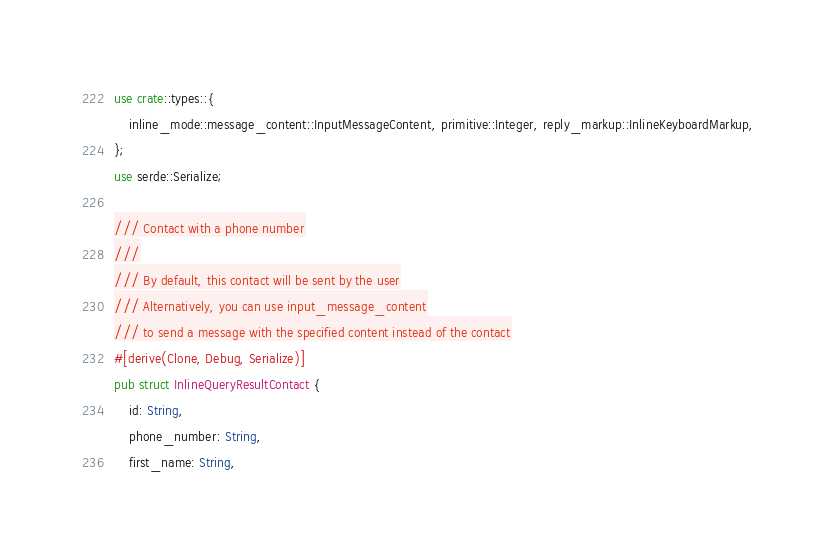<code> <loc_0><loc_0><loc_500><loc_500><_Rust_>use crate::types::{
    inline_mode::message_content::InputMessageContent, primitive::Integer, reply_markup::InlineKeyboardMarkup,
};
use serde::Serialize;

/// Contact with a phone number
///
/// By default, this contact will be sent by the user
/// Alternatively, you can use input_message_content
/// to send a message with the specified content instead of the contact
#[derive(Clone, Debug, Serialize)]
pub struct InlineQueryResultContact {
    id: String,
    phone_number: String,
    first_name: String,</code> 